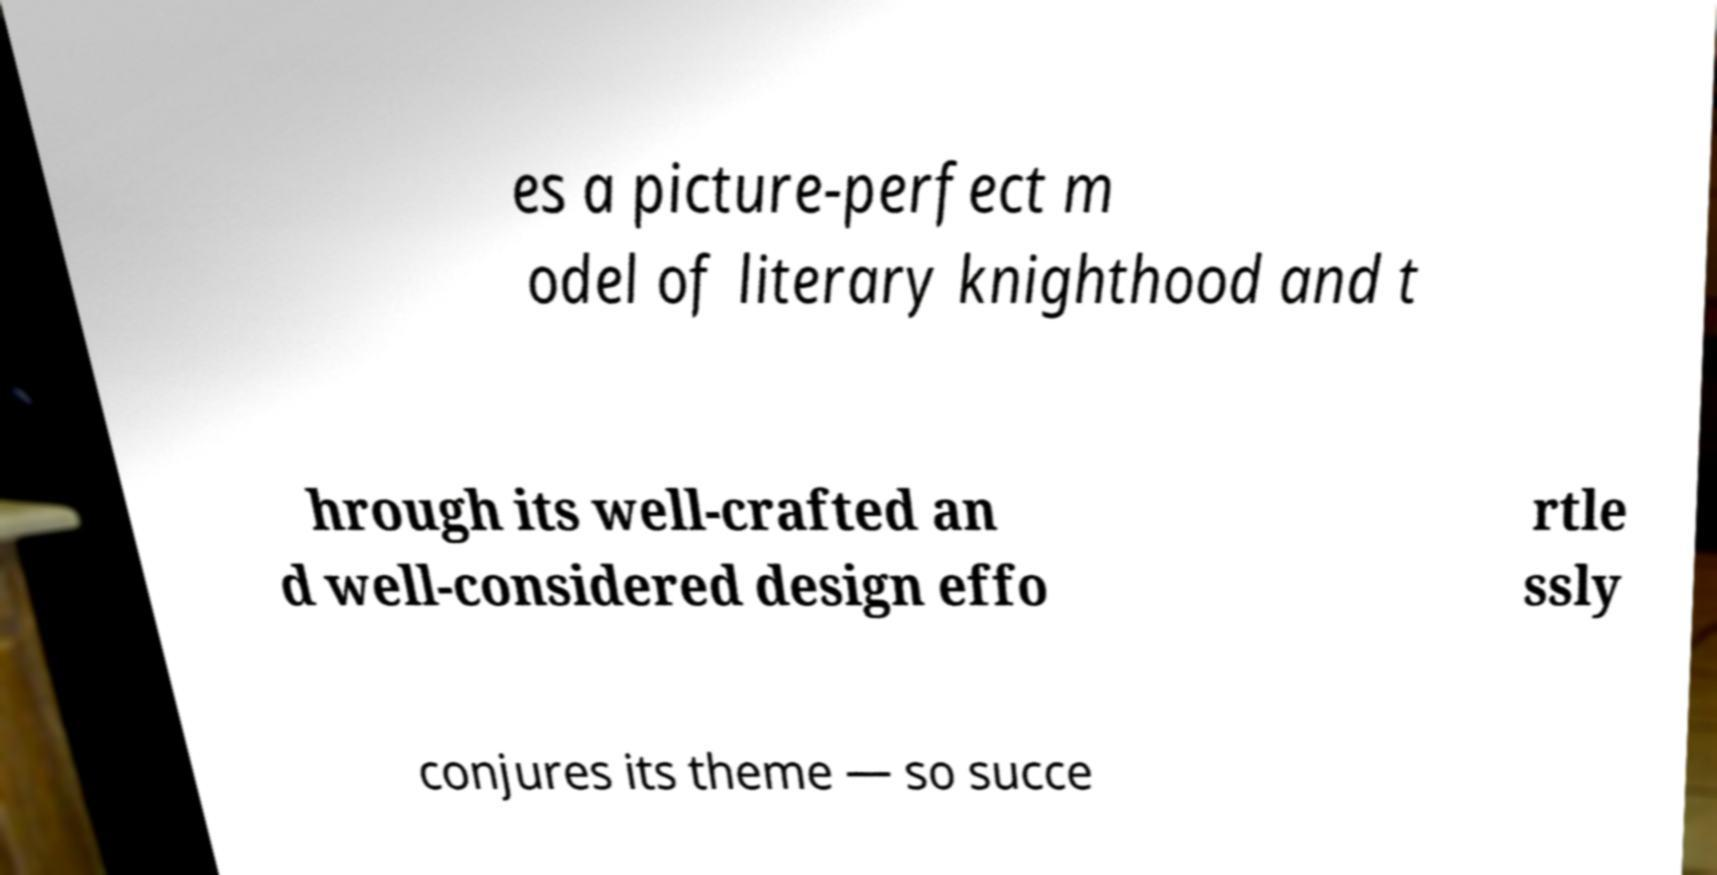Can you accurately transcribe the text from the provided image for me? es a picture-perfect m odel of literary knighthood and t hrough its well-crafted an d well-considered design effo rtle ssly conjures its theme — so succe 